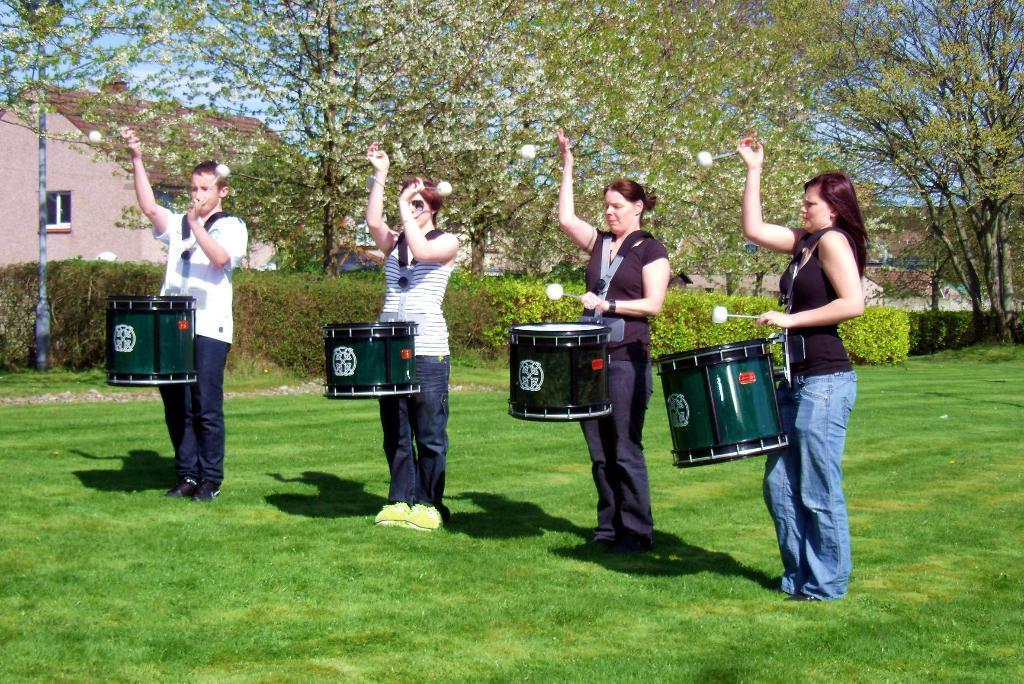Describe this image in one or two sentences. There are four persons carrying drums and holding a drum sticks in their hands and the ground is greenery and there are trees and buildings behind them. 